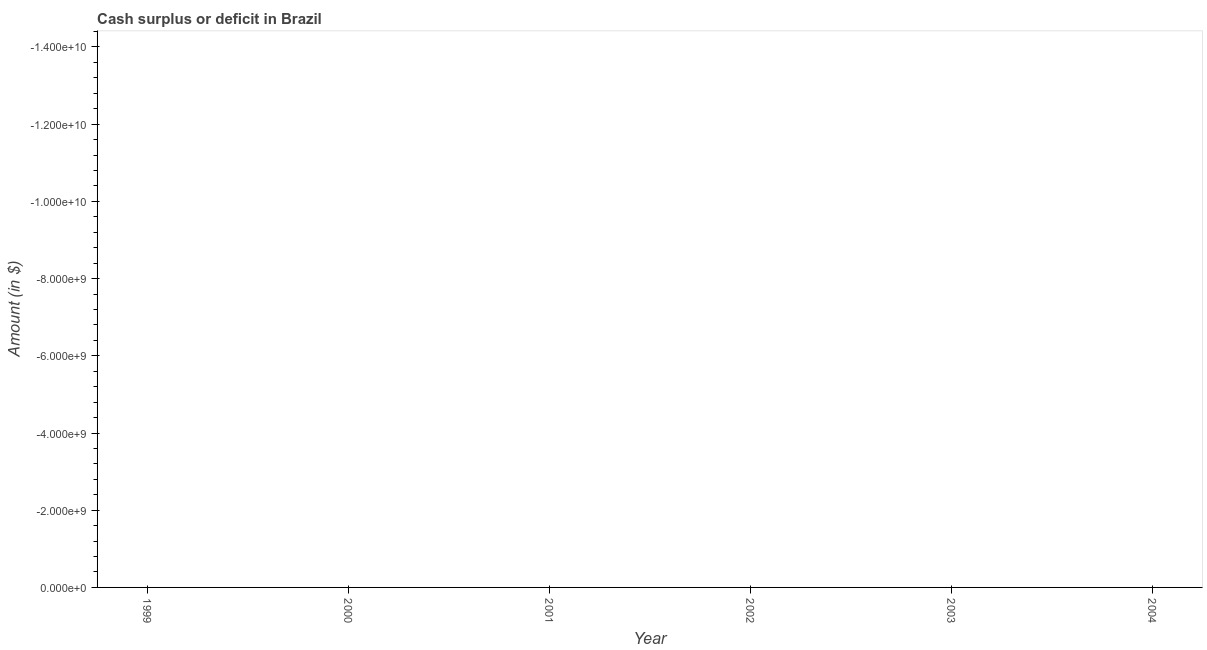Across all years, what is the minimum cash surplus or deficit?
Offer a terse response. 0. What is the average cash surplus or deficit per year?
Provide a short and direct response. 0. In how many years, is the cash surplus or deficit greater than -6800000000 $?
Give a very brief answer. 0. In how many years, is the cash surplus or deficit greater than the average cash surplus or deficit taken over all years?
Offer a very short reply. 0. Does the cash surplus or deficit monotonically increase over the years?
Offer a terse response. No. How many years are there in the graph?
Give a very brief answer. 6. Does the graph contain any zero values?
Offer a very short reply. Yes. What is the title of the graph?
Offer a terse response. Cash surplus or deficit in Brazil. What is the label or title of the Y-axis?
Keep it short and to the point. Amount (in $). What is the Amount (in $) of 2002?
Your response must be concise. 0. What is the Amount (in $) of 2003?
Your answer should be compact. 0. What is the Amount (in $) in 2004?
Ensure brevity in your answer.  0. 